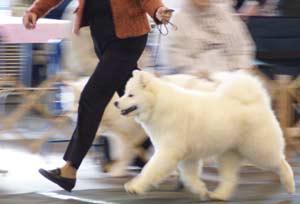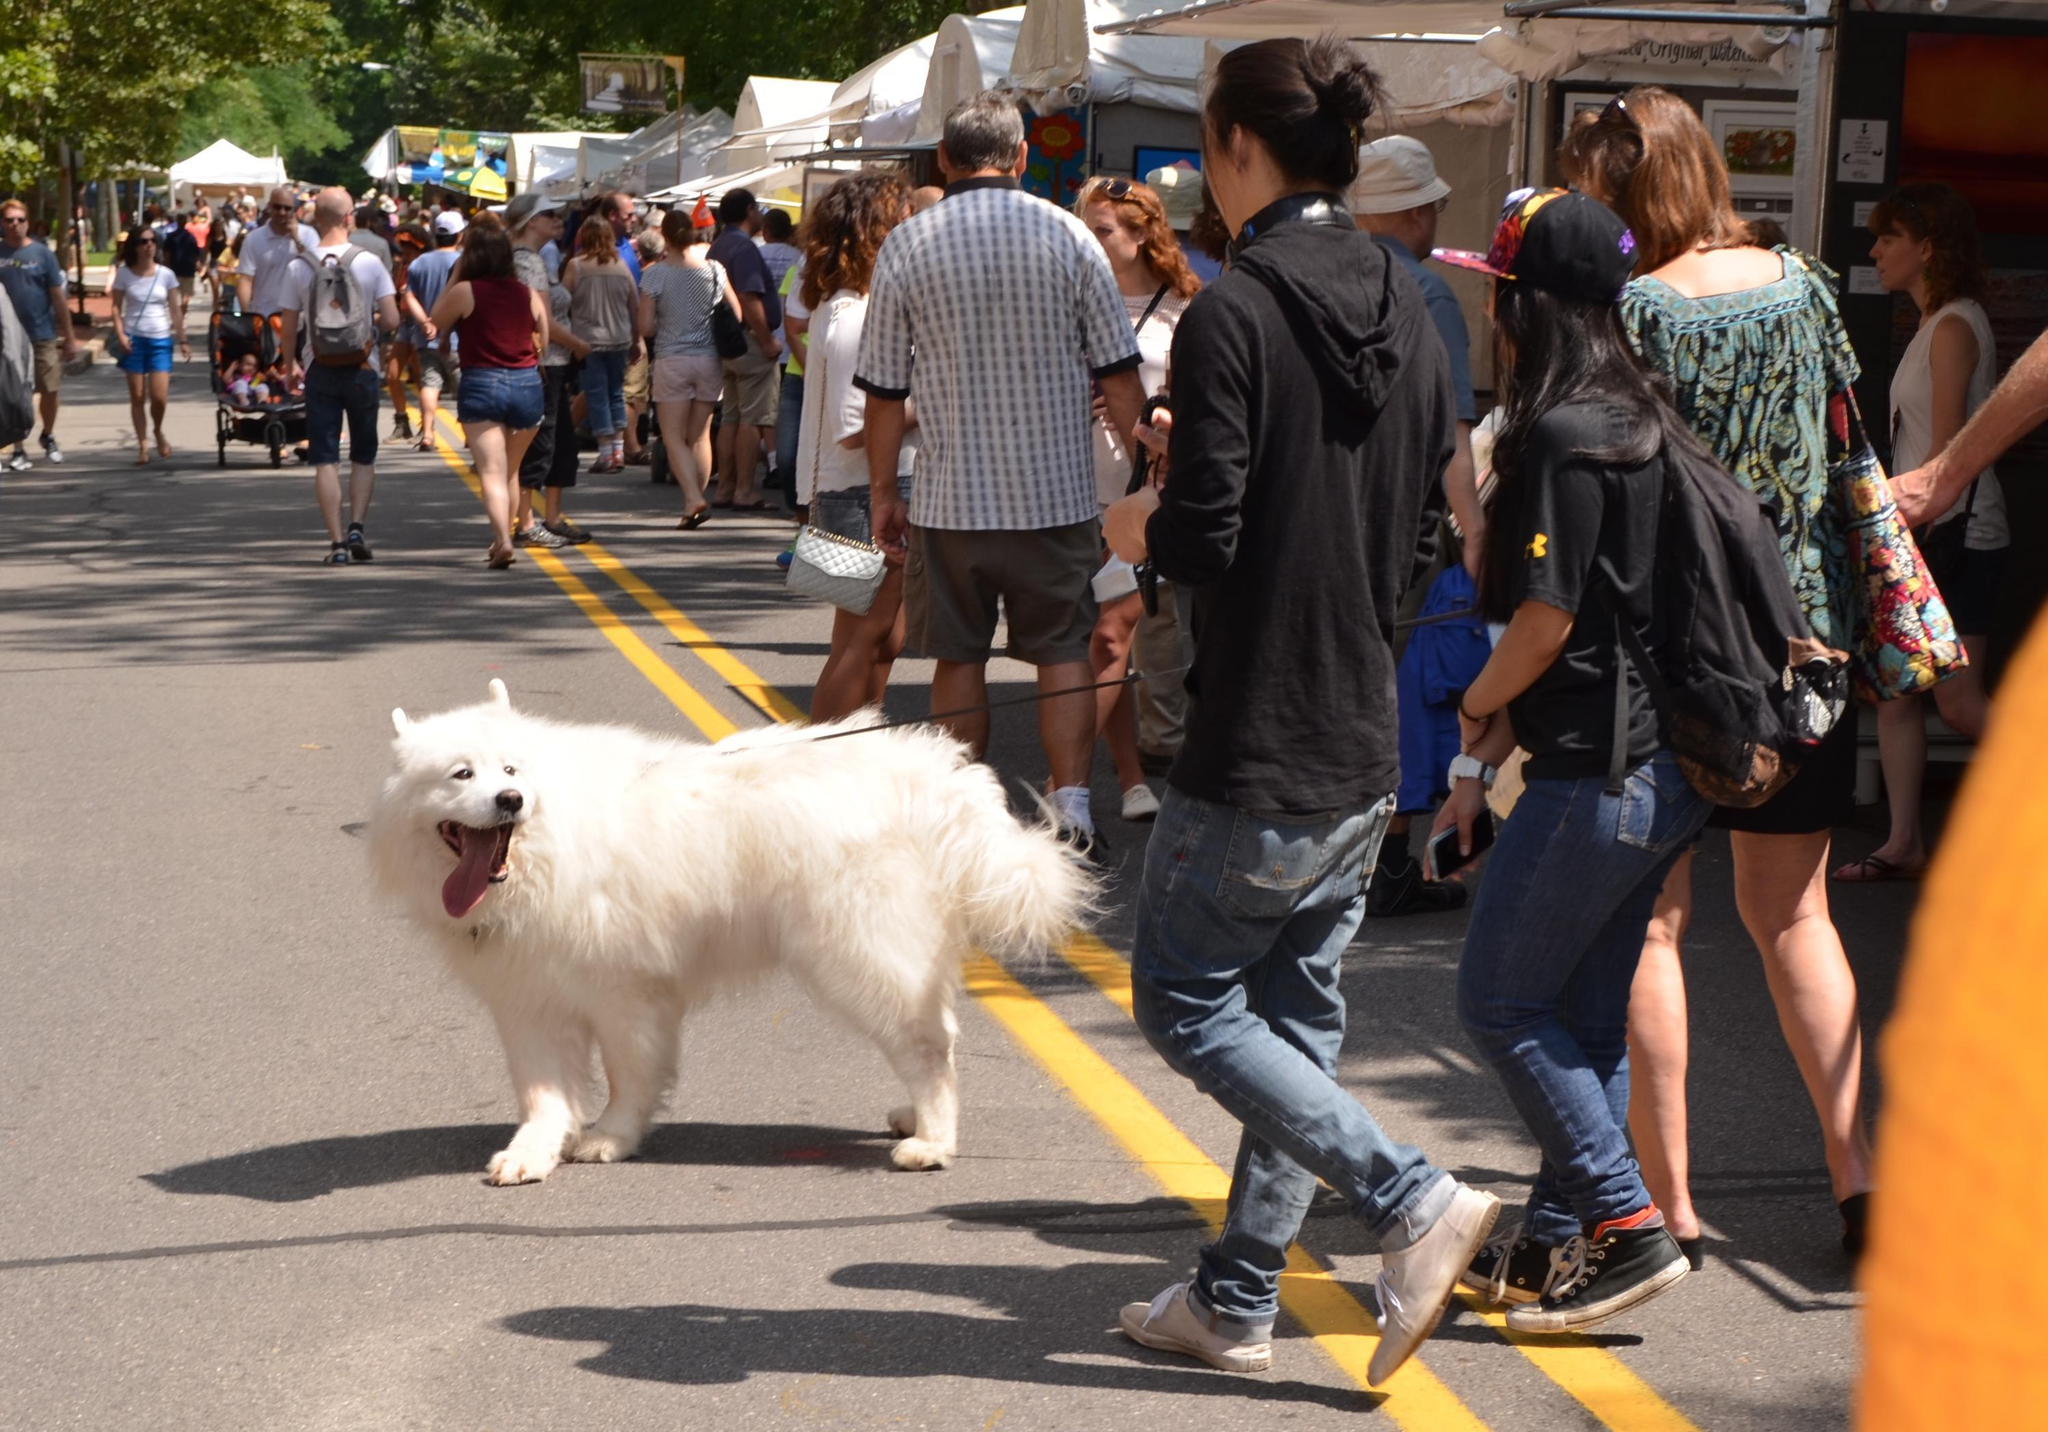The first image is the image on the left, the second image is the image on the right. Considering the images on both sides, is "One image features a man in a suit reaching toward a standing white dog in front of white lattice fencing, and the other image features a team of hitched white dogs with a rider behind them." valid? Answer yes or no. No. 